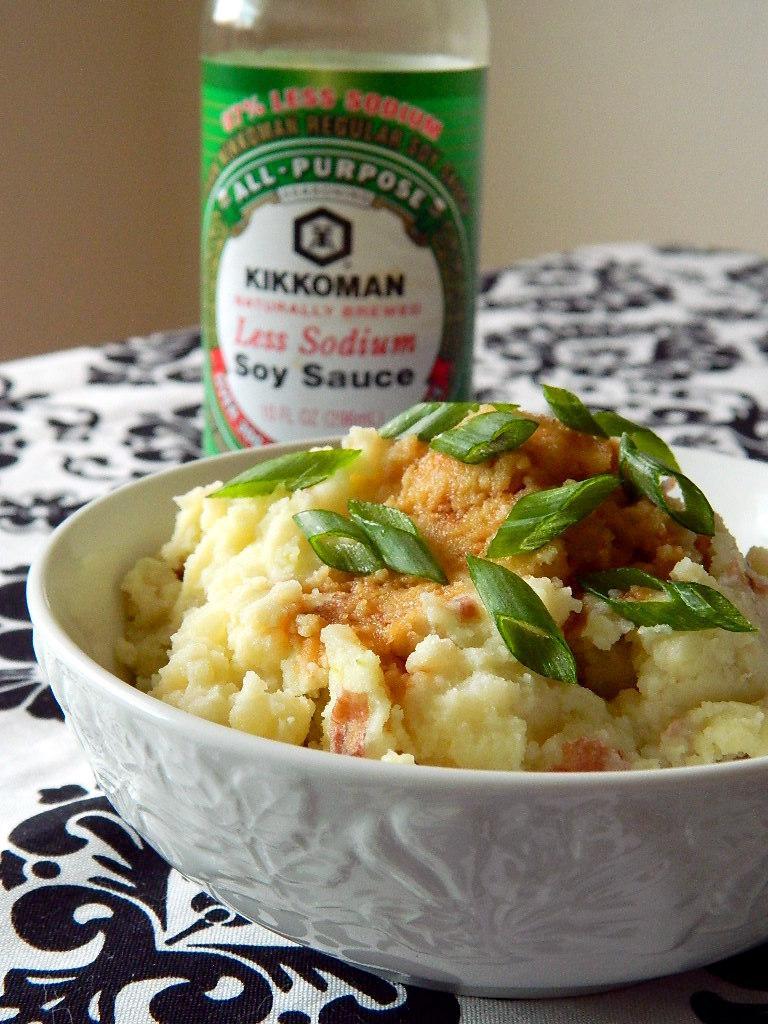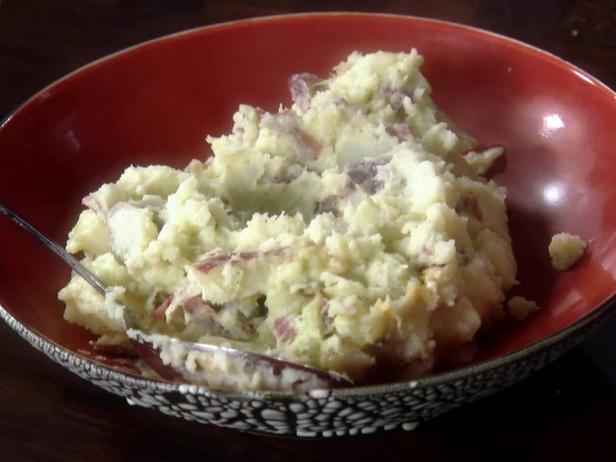The first image is the image on the left, the second image is the image on the right. For the images shown, is this caption "Green garnishes are sprinkled over both dishes." true? Answer yes or no. No. The first image is the image on the left, the second image is the image on the right. For the images displayed, is the sentence "Left image shows food served in a white, non-square dish with textured design." factually correct? Answer yes or no. Yes. 